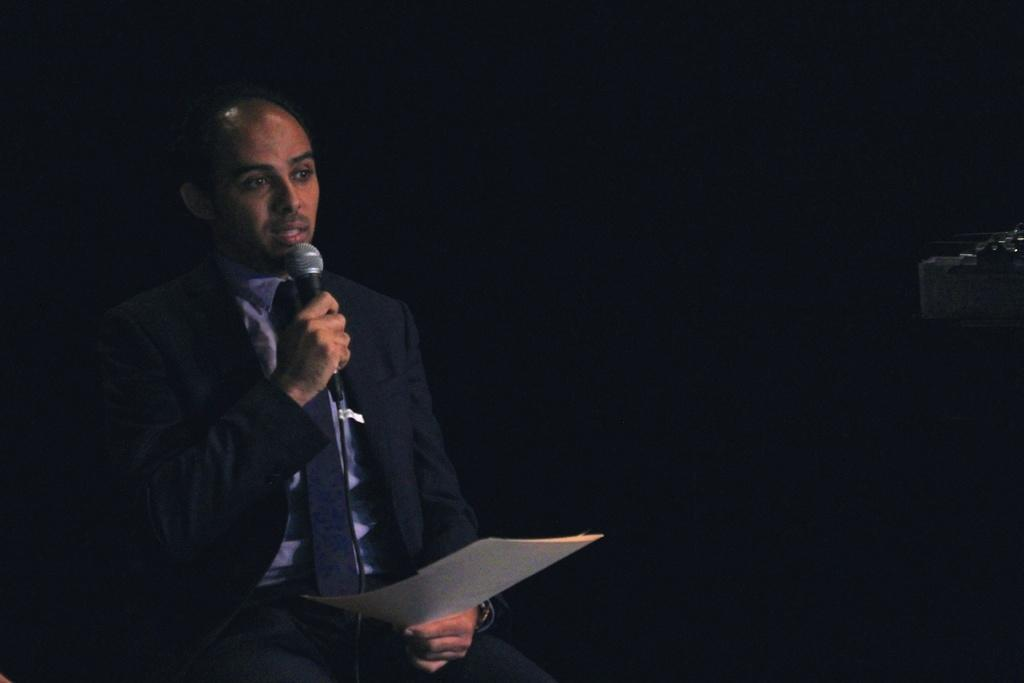What is the person in the image wearing? The person is wearing a black suit. What is the person holding in their right hand? The person is holding a mic in their right hand. What is the person holding in their left hand? The person is holding a paper in their left hand. What is the person sitting on in the image? The person is sitting on a stool. Can you see a lake in the background of the image? There is no lake visible in the image. 